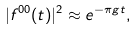Convert formula to latex. <formula><loc_0><loc_0><loc_500><loc_500>| f ^ { 0 0 } ( t ) | ^ { 2 } \approx e ^ { - \pi g t } ,</formula> 